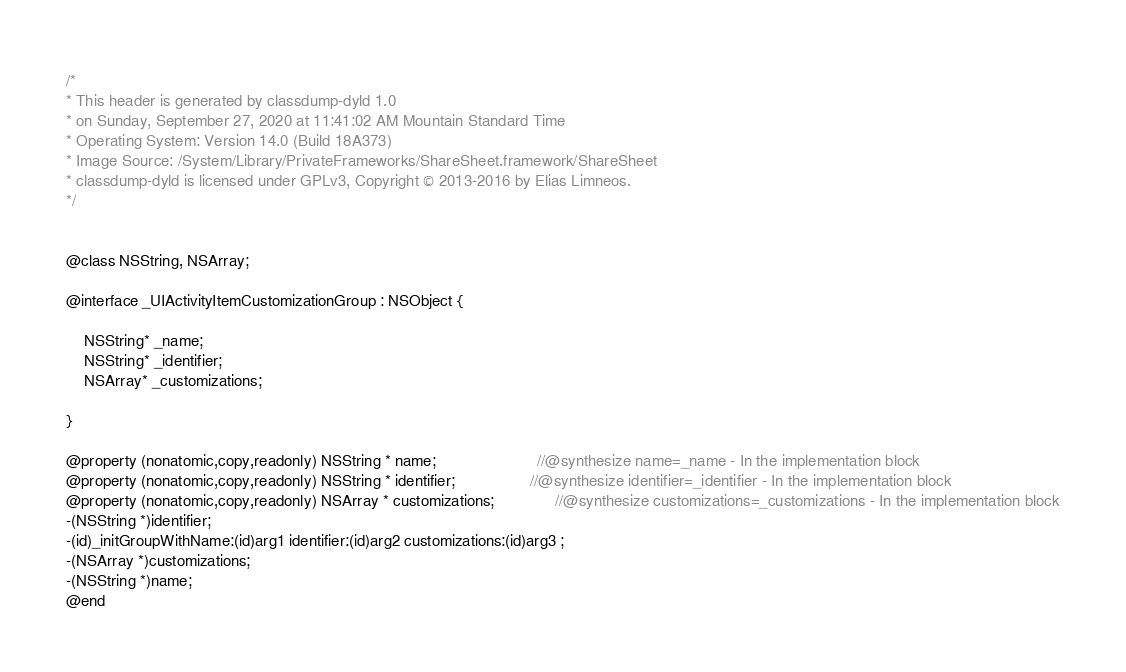Convert code to text. <code><loc_0><loc_0><loc_500><loc_500><_C_>/*
* This header is generated by classdump-dyld 1.0
* on Sunday, September 27, 2020 at 11:41:02 AM Mountain Standard Time
* Operating System: Version 14.0 (Build 18A373)
* Image Source: /System/Library/PrivateFrameworks/ShareSheet.framework/ShareSheet
* classdump-dyld is licensed under GPLv3, Copyright © 2013-2016 by Elias Limneos.
*/


@class NSString, NSArray;

@interface _UIActivityItemCustomizationGroup : NSObject {

	NSString* _name;
	NSString* _identifier;
	NSArray* _customizations;

}

@property (nonatomic,copy,readonly) NSString * name;                       //@synthesize name=_name - In the implementation block
@property (nonatomic,copy,readonly) NSString * identifier;                 //@synthesize identifier=_identifier - In the implementation block
@property (nonatomic,copy,readonly) NSArray * customizations;              //@synthesize customizations=_customizations - In the implementation block
-(NSString *)identifier;
-(id)_initGroupWithName:(id)arg1 identifier:(id)arg2 customizations:(id)arg3 ;
-(NSArray *)customizations;
-(NSString *)name;
@end

</code> 